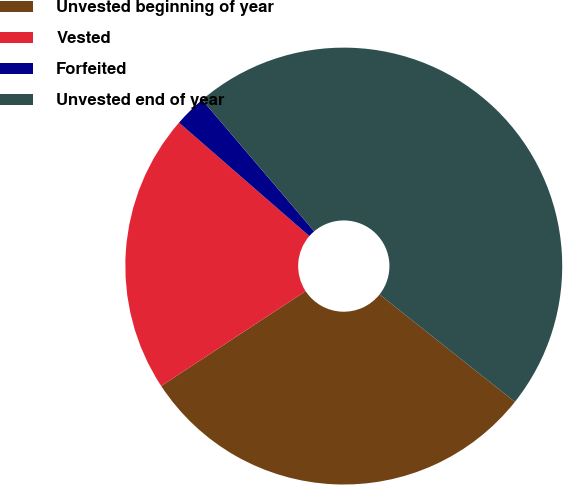<chart> <loc_0><loc_0><loc_500><loc_500><pie_chart><fcel>Unvested beginning of year<fcel>Vested<fcel>Forfeited<fcel>Unvested end of year<nl><fcel>30.08%<fcel>20.65%<fcel>2.37%<fcel>46.91%<nl></chart> 